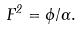Convert formula to latex. <formula><loc_0><loc_0><loc_500><loc_500>F ^ { 2 } = \phi / \Gamma .</formula> 